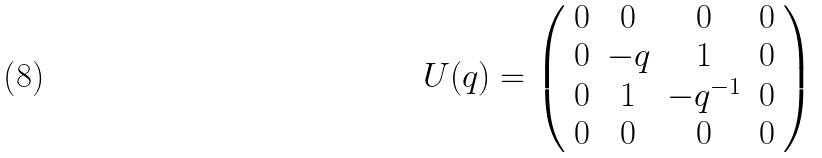<formula> <loc_0><loc_0><loc_500><loc_500>U ( q ) = \left ( \begin{array} { c c c c } 0 & 0 & 0 & 0 \\ 0 & - q & 1 & 0 \\ 0 & 1 & - q ^ { - 1 } & 0 \\ 0 & 0 & 0 & 0 \end{array} \right )</formula> 